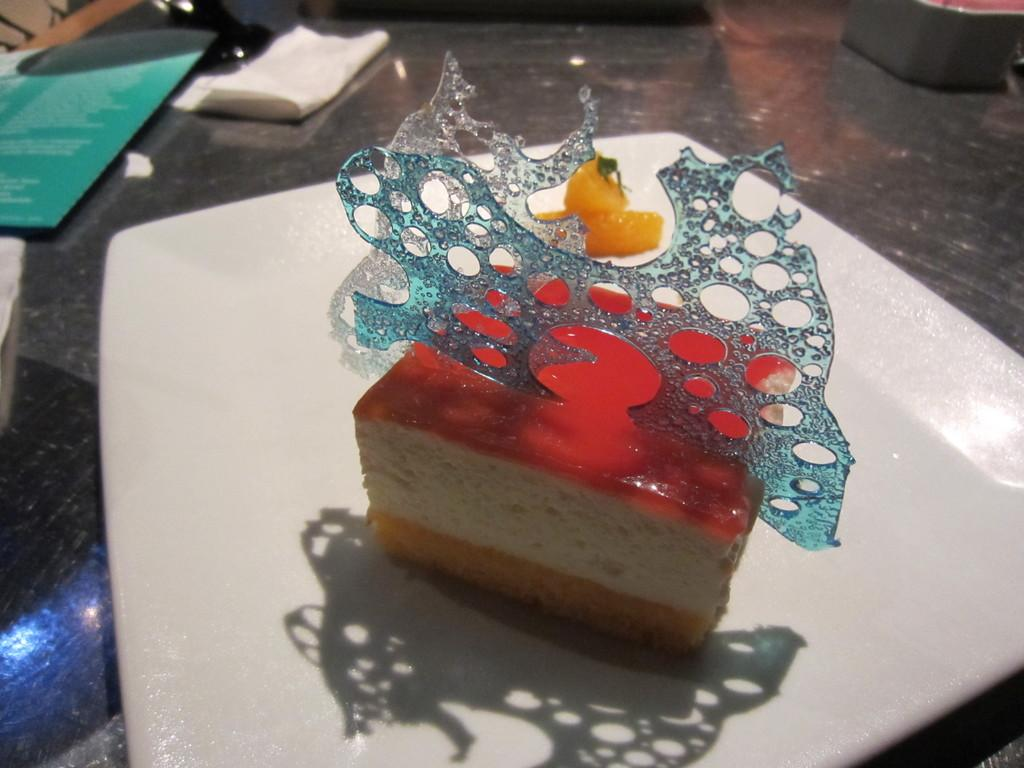What is on the plate that is visible in the image? There is a pastry on a plate in the image. Where is the plate located in the image? The plate is on a table in the image. What items might be used for cleaning or wiping in the image? Tissue papers are present in the image for cleaning or wiping. What might be used for selecting food items in the image? There is a menu card in the image for selecting food items. Is the queen sitting on a chair in the image? There is no queen or chair present in the image. What type of knowledge can be gained from the pastry in the image? The pastry does not convey any knowledge; it is a food item. 